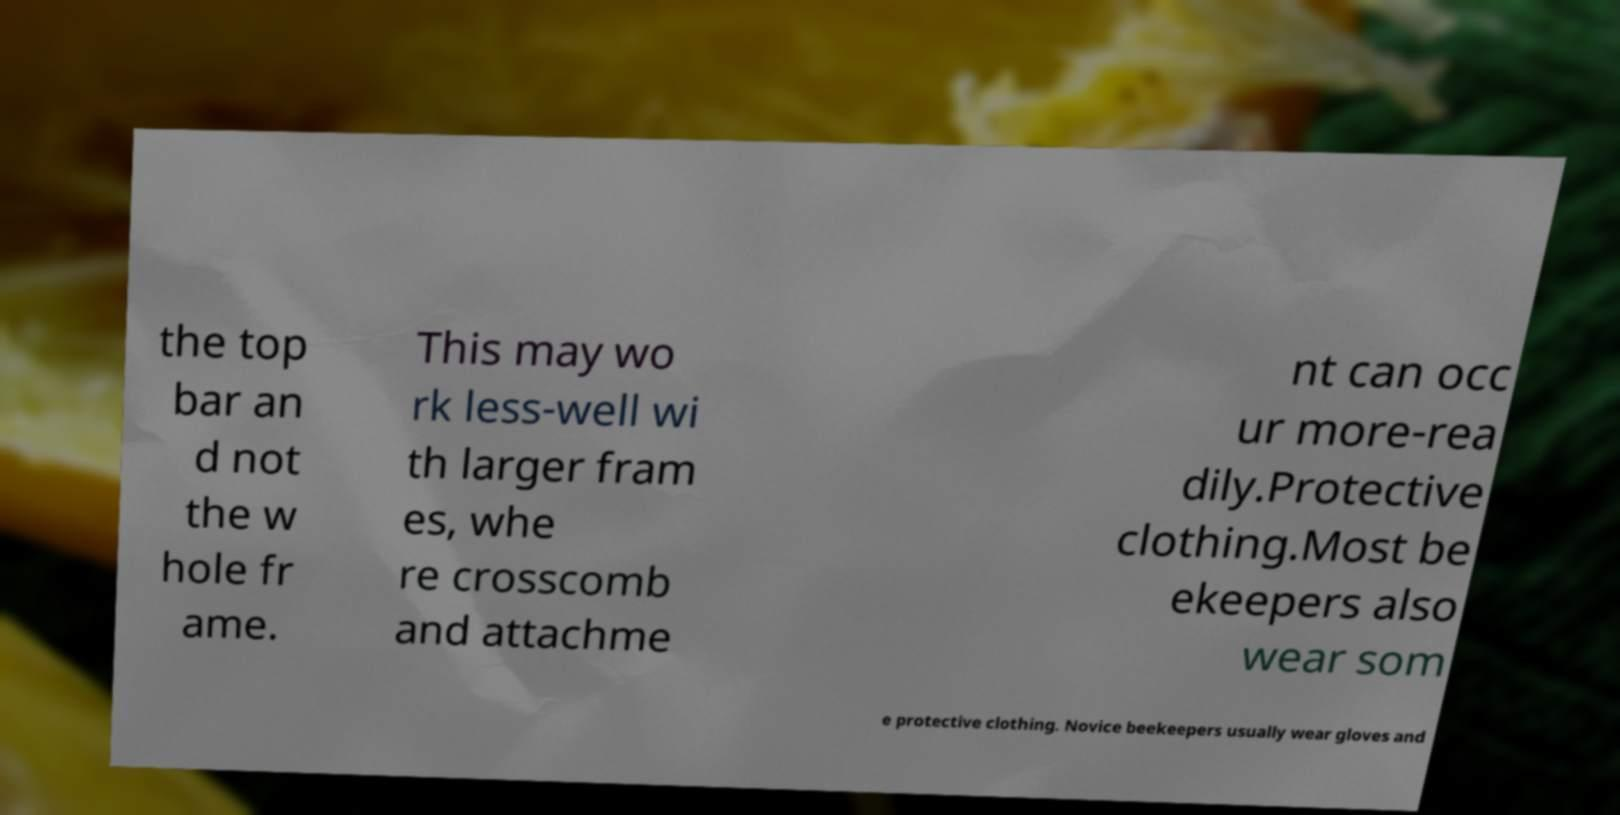Can you accurately transcribe the text from the provided image for me? the top bar an d not the w hole fr ame. This may wo rk less-well wi th larger fram es, whe re crosscomb and attachme nt can occ ur more-rea dily.Protective clothing.Most be ekeepers also wear som e protective clothing. Novice beekeepers usually wear gloves and 